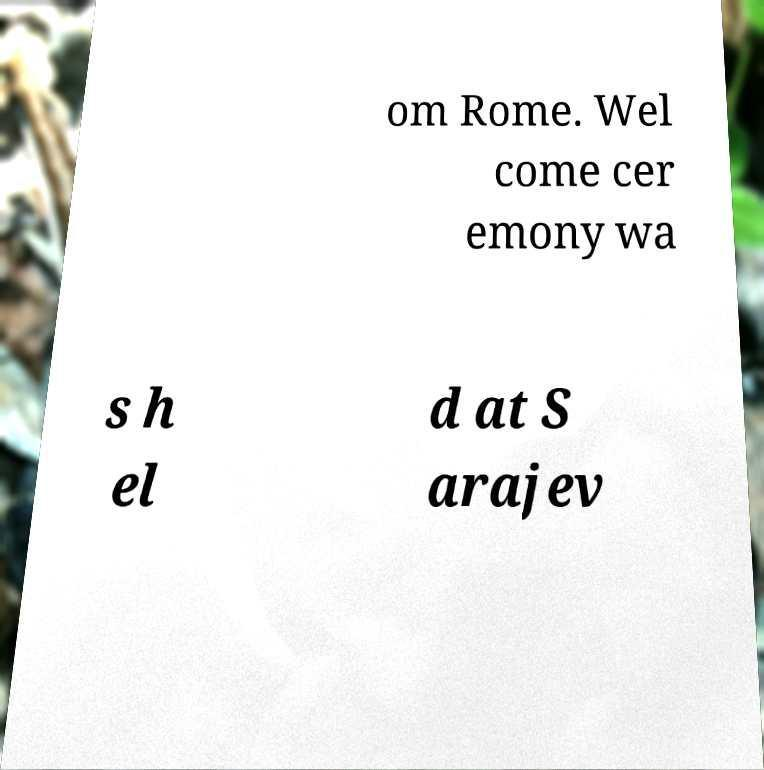Can you read and provide the text displayed in the image?This photo seems to have some interesting text. Can you extract and type it out for me? om Rome. Wel come cer emony wa s h el d at S arajev 